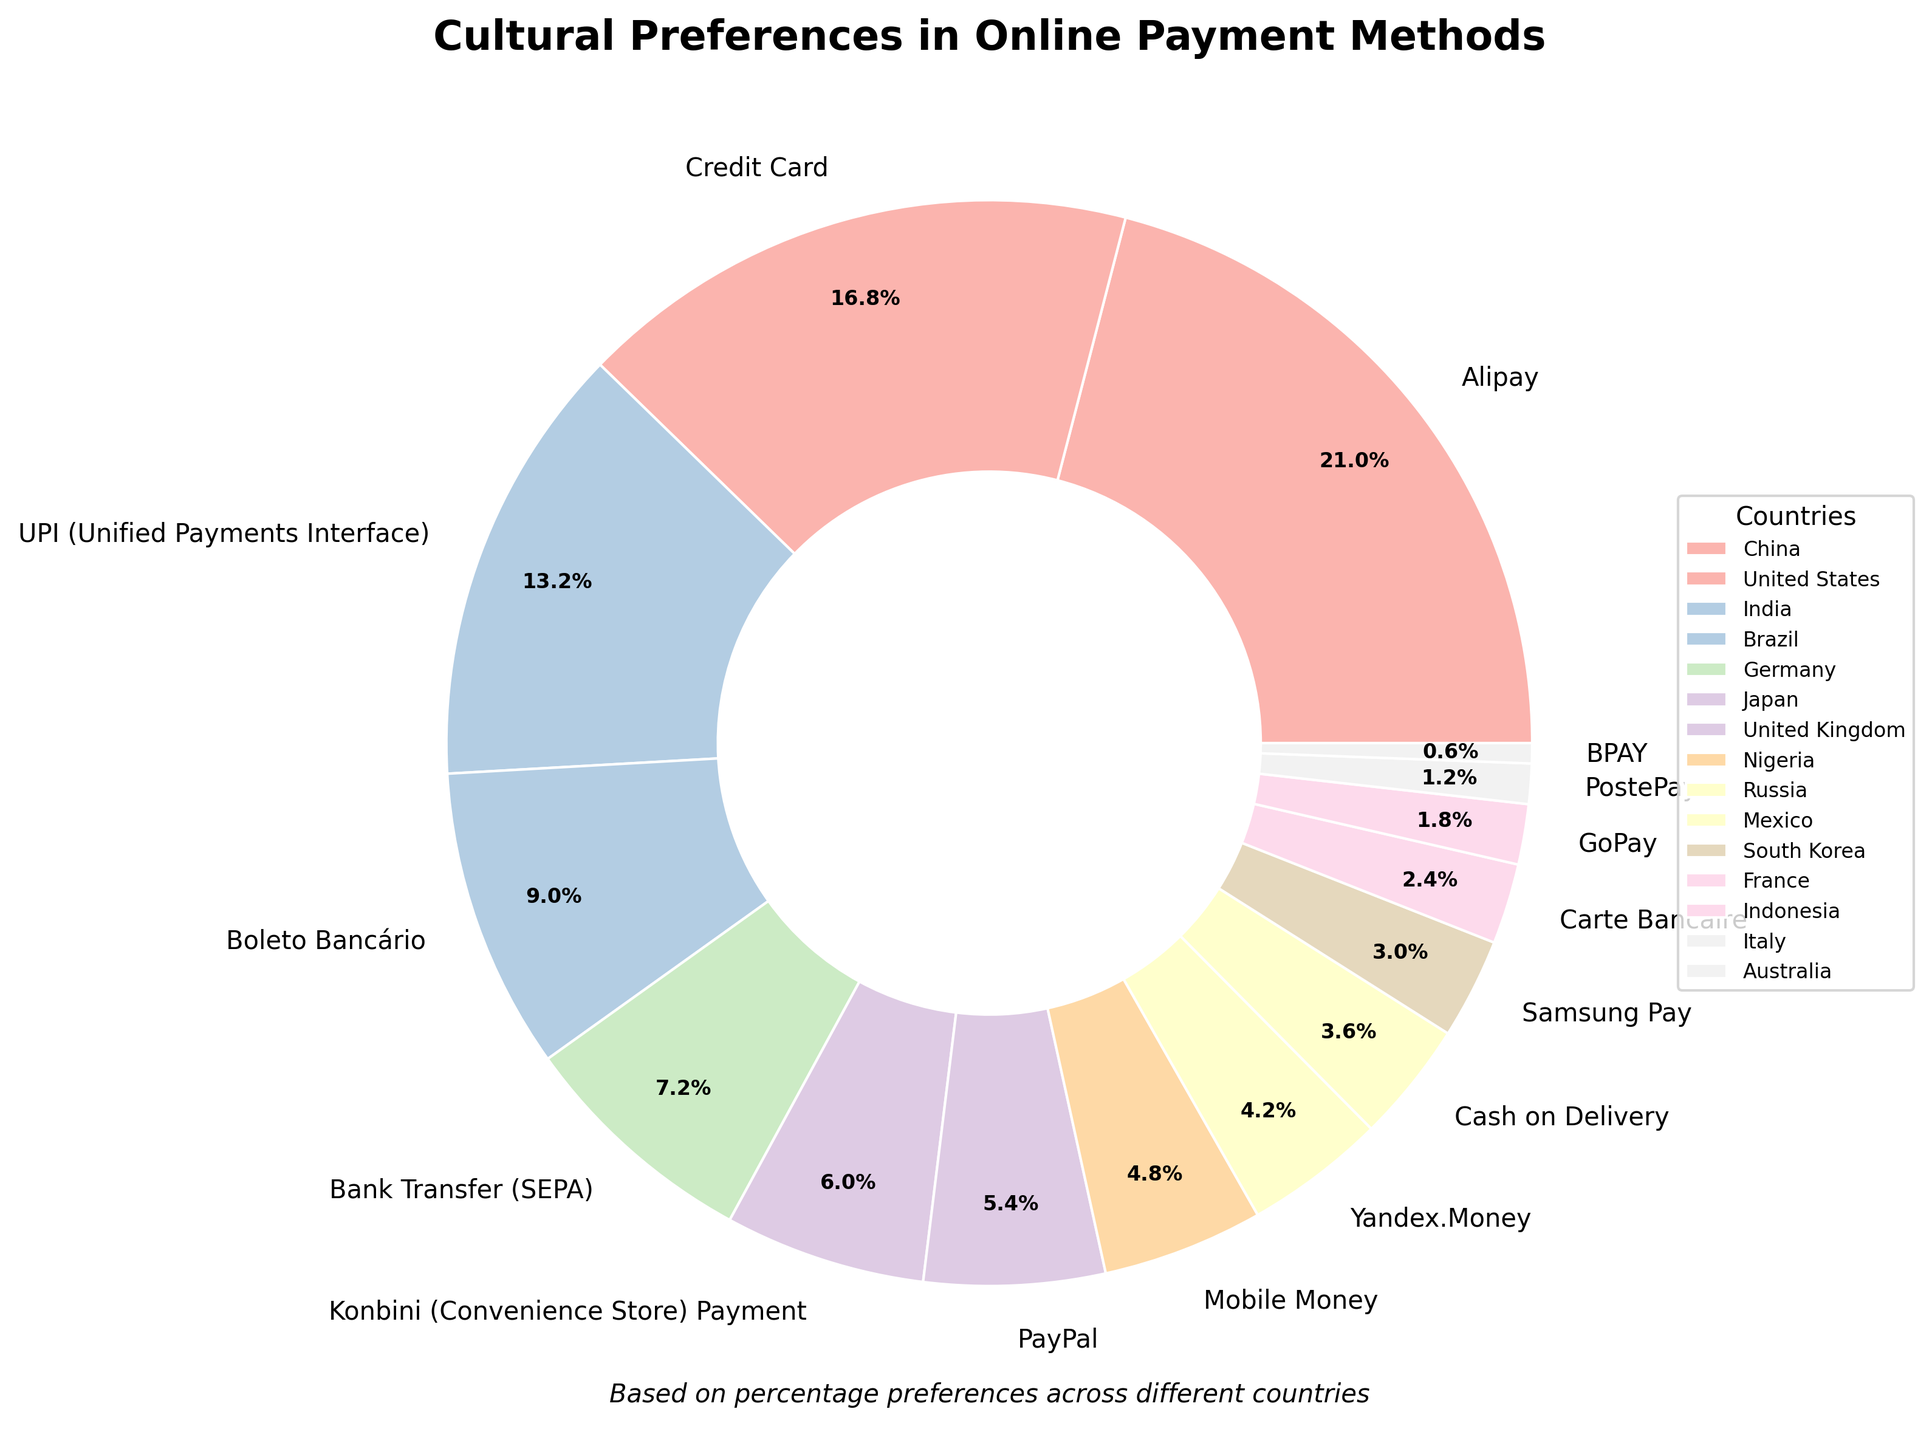Which country has the highest percentage preference for an online payment method? Look at the chart to identify the largest section. The largest portion represents China with a 35% preference for Alipay.
Answer: China Which country prefers Credit Card, and what is the percentage? Find the section labeled "Credit Card" and check the corresponding country and percentage. The United States prefers Credit Card with a 28% preference.
Answer: United States, 28% What is the total combined percentage of countries that prefer PayPal, GoPay, and Yandex.Money? Identify the percentages for PayPal (9%), GoPay (3%), and Yandex.Money (7%). Add these values together: 9% + 3% + 7% = 19%.
Answer: 19% Which payment method is preferred by Japan, and what is its percentage? Locate Japan in the legend and find the corresponding section in the chart. Japan prefers Konbini (Convenience Store) Payment with a 10% preference.
Answer: Konbini (Convenience Store) Payment, 10% Which countries have a preferred payment method with less than a 10% preference? Identify sections and countries with percentages less than 10%. These countries are United Kingdom (PayPal, 9%), Nigeria (Mobile Money, 8%), Russia (Yandex.Money, 7%), Mexico (Cash on Delivery, 6%), South Korea (Samsung Pay, 5%), France (Carte Bancaire, 4%), Indonesia (GoPay, 3%), Italy (PostePay, 2%), Australia (BPAY, 1%).
Answer: United Kingdom, Nigeria, Russia, Mexico, South Korea, France, Indonesia, Italy, Australia How much greater is the percentage of China’s preferred payment method compared to Germany’s? Locate the sections for China (35%) and Germany (12%). Calculate the difference: 35% - 12% = 23%.
Answer: 23% What are the payment methods and percentages for India and Brazil combined? Identify and add India (UPI, 22%) and Brazil (Boleto Bancário, 15%) percentages. State their payment methods together. Combined, they are UPI (22%) and Boleto Bancário (15%) with a total percentage of 22% + 15% = 37%.
Answer: UPI (22%), Boleto Bancário (15%) Which payment method is preferred by the smallest percentage of users, and what country is it associated with? Identify the smallest section in the chart. BPAY is preferred by 1% of users and is associated with Australia.
Answer: BPAY, Australia 